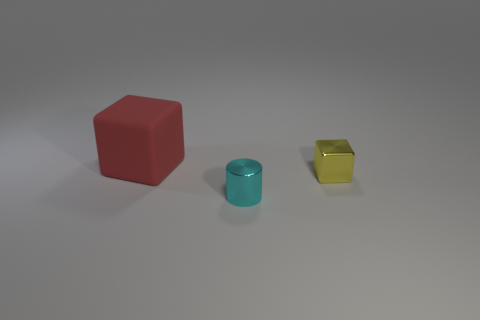Add 2 small yellow metallic objects. How many objects exist? 5 Subtract all yellow cubes. How many cubes are left? 1 Subtract all blocks. How many objects are left? 1 Subtract all red blocks. Subtract all gray cylinders. How many blocks are left? 1 Subtract all big yellow matte spheres. Subtract all cyan metal cylinders. How many objects are left? 2 Add 3 yellow shiny cubes. How many yellow shiny cubes are left? 4 Add 1 large blocks. How many large blocks exist? 2 Subtract 0 gray balls. How many objects are left? 3 